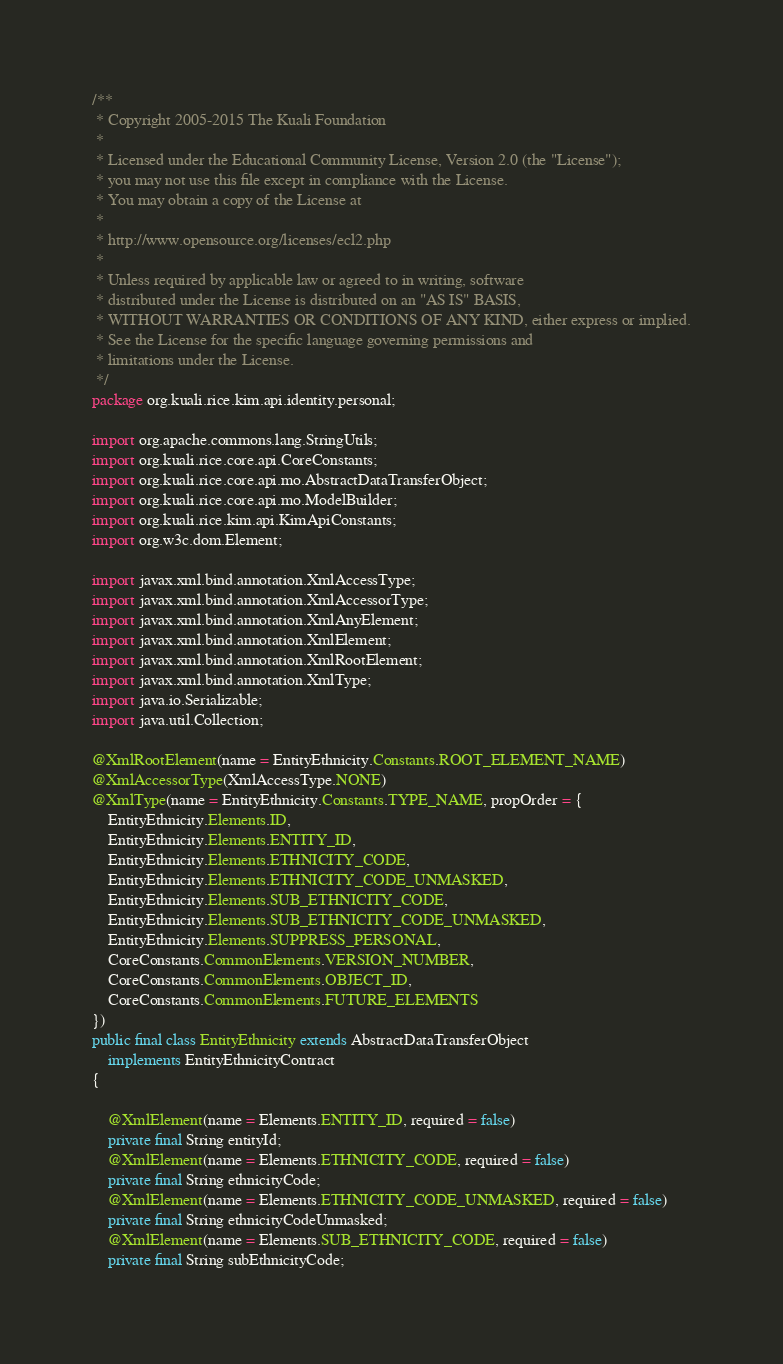Convert code to text. <code><loc_0><loc_0><loc_500><loc_500><_Java_>/**
 * Copyright 2005-2015 The Kuali Foundation
 *
 * Licensed under the Educational Community License, Version 2.0 (the "License");
 * you may not use this file except in compliance with the License.
 * You may obtain a copy of the License at
 *
 * http://www.opensource.org/licenses/ecl2.php
 *
 * Unless required by applicable law or agreed to in writing, software
 * distributed under the License is distributed on an "AS IS" BASIS,
 * WITHOUT WARRANTIES OR CONDITIONS OF ANY KIND, either express or implied.
 * See the License for the specific language governing permissions and
 * limitations under the License.
 */
package org.kuali.rice.kim.api.identity.personal;

import org.apache.commons.lang.StringUtils;
import org.kuali.rice.core.api.CoreConstants;
import org.kuali.rice.core.api.mo.AbstractDataTransferObject;
import org.kuali.rice.core.api.mo.ModelBuilder;
import org.kuali.rice.kim.api.KimApiConstants;
import org.w3c.dom.Element;

import javax.xml.bind.annotation.XmlAccessType;
import javax.xml.bind.annotation.XmlAccessorType;
import javax.xml.bind.annotation.XmlAnyElement;
import javax.xml.bind.annotation.XmlElement;
import javax.xml.bind.annotation.XmlRootElement;
import javax.xml.bind.annotation.XmlType;
import java.io.Serializable;
import java.util.Collection;

@XmlRootElement(name = EntityEthnicity.Constants.ROOT_ELEMENT_NAME)
@XmlAccessorType(XmlAccessType.NONE)
@XmlType(name = EntityEthnicity.Constants.TYPE_NAME, propOrder = {
    EntityEthnicity.Elements.ID,
    EntityEthnicity.Elements.ENTITY_ID,
    EntityEthnicity.Elements.ETHNICITY_CODE,
    EntityEthnicity.Elements.ETHNICITY_CODE_UNMASKED,
    EntityEthnicity.Elements.SUB_ETHNICITY_CODE,
    EntityEthnicity.Elements.SUB_ETHNICITY_CODE_UNMASKED,
    EntityEthnicity.Elements.SUPPRESS_PERSONAL,
    CoreConstants.CommonElements.VERSION_NUMBER,
    CoreConstants.CommonElements.OBJECT_ID,
    CoreConstants.CommonElements.FUTURE_ELEMENTS
})
public final class EntityEthnicity extends AbstractDataTransferObject
    implements EntityEthnicityContract
{

    @XmlElement(name = Elements.ENTITY_ID, required = false)
    private final String entityId;
    @XmlElement(name = Elements.ETHNICITY_CODE, required = false)
    private final String ethnicityCode;
    @XmlElement(name = Elements.ETHNICITY_CODE_UNMASKED, required = false)
    private final String ethnicityCodeUnmasked;
    @XmlElement(name = Elements.SUB_ETHNICITY_CODE, required = false)
    private final String subEthnicityCode;</code> 